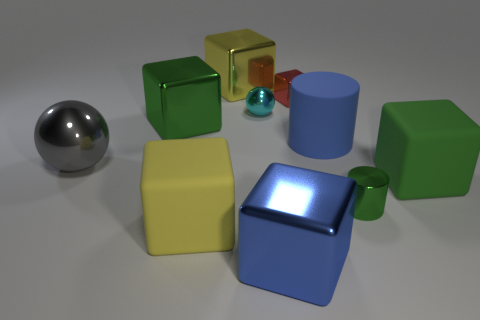Subtract all big blue cubes. How many cubes are left? 5 Subtract all green cubes. How many cubes are left? 4 Subtract all gray cubes. Subtract all red cylinders. How many cubes are left? 6 Subtract all cylinders. How many objects are left? 8 Add 7 large cylinders. How many large cylinders exist? 8 Subtract 0 purple balls. How many objects are left? 10 Subtract all tiny cyan metallic things. Subtract all tiny metallic cubes. How many objects are left? 8 Add 6 tiny cyan objects. How many tiny cyan objects are left? 7 